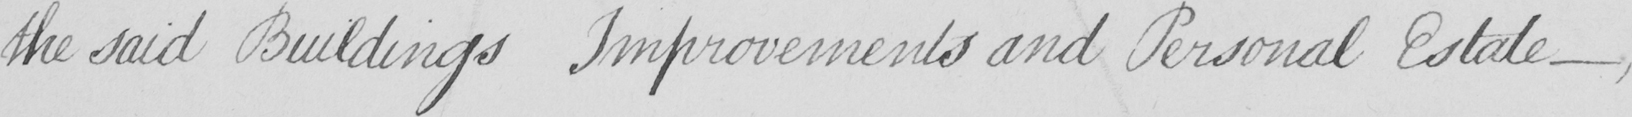What text is written in this handwritten line? the said Buildings Improvements and Personal Estate _ 